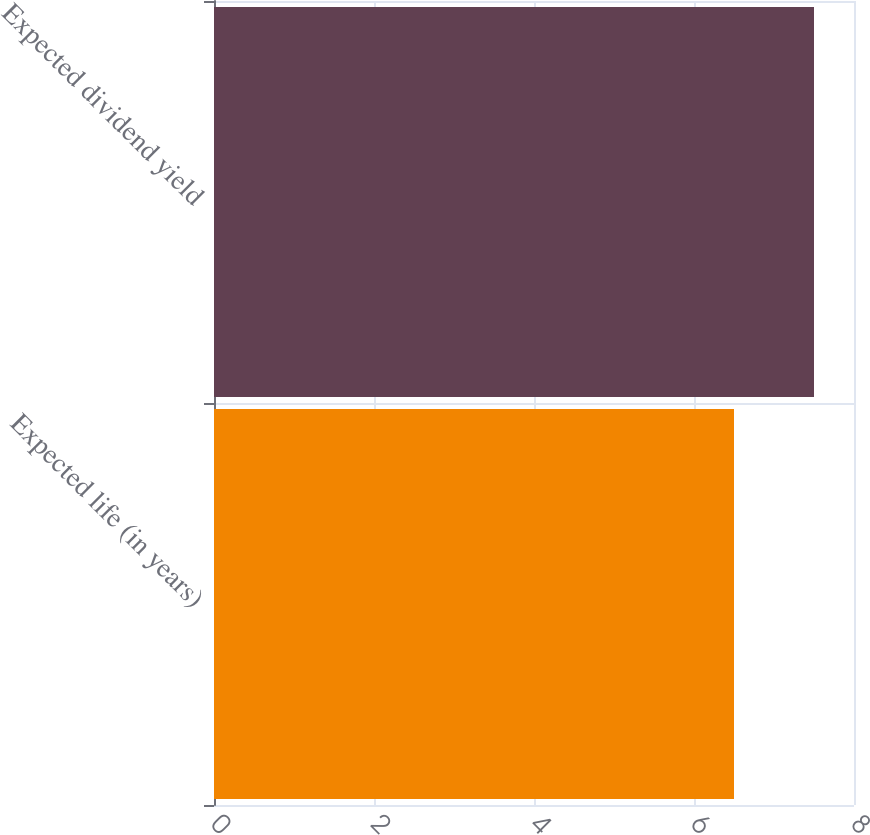Convert chart to OTSL. <chart><loc_0><loc_0><loc_500><loc_500><bar_chart><fcel>Expected life (in years)<fcel>Expected dividend yield<nl><fcel>6.5<fcel>7.5<nl></chart> 